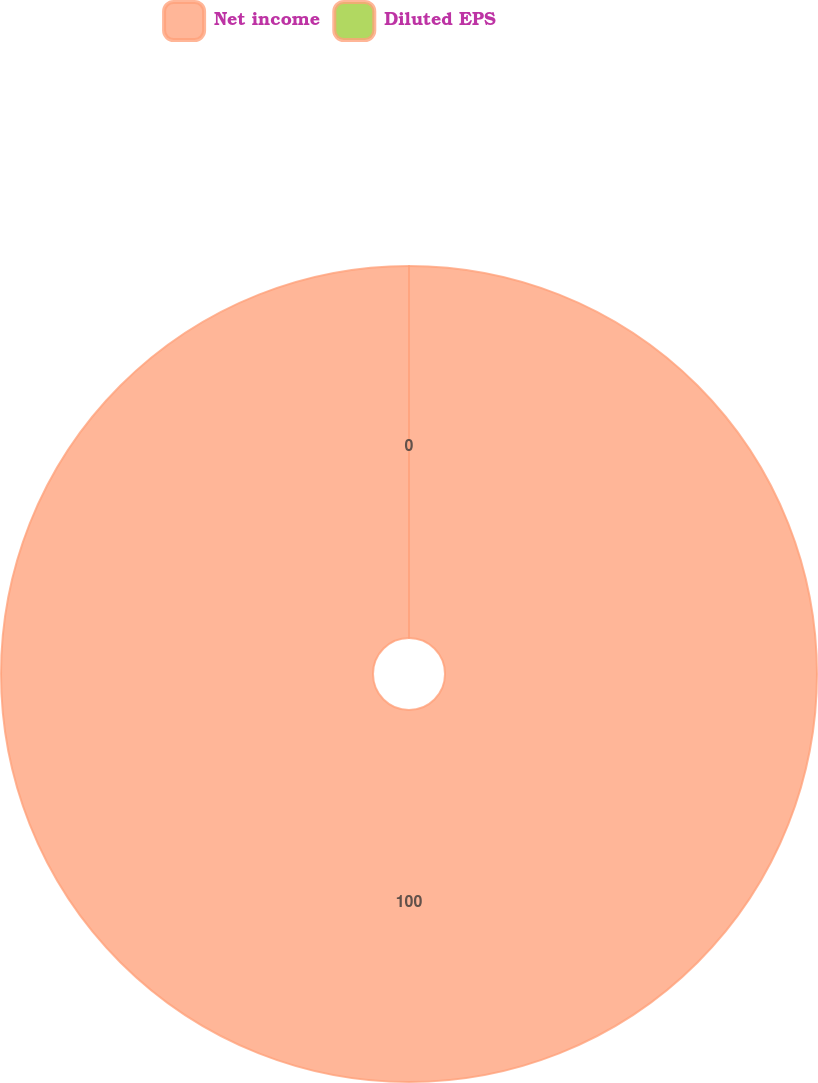Convert chart to OTSL. <chart><loc_0><loc_0><loc_500><loc_500><pie_chart><fcel>Net income<fcel>Diluted EPS<nl><fcel>100.0%<fcel>0.0%<nl></chart> 